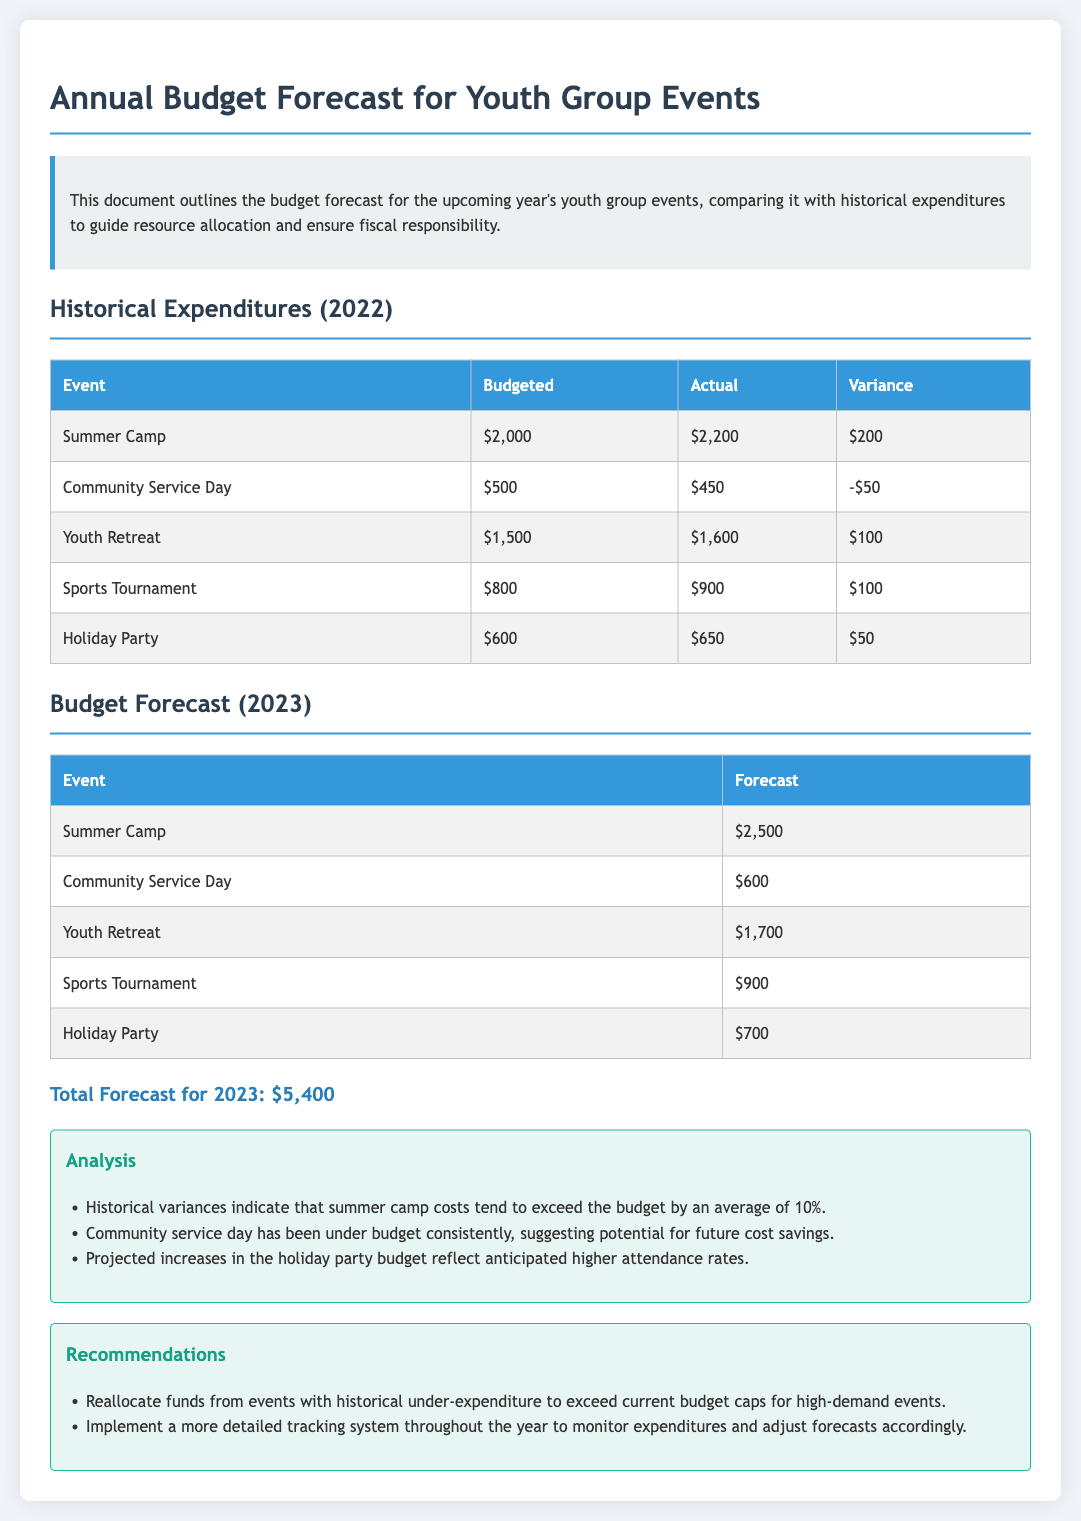What is the total budget for Summer Camp? The budget for Summer Camp in 2022 is listed as $2,000.
Answer: $2,000 What was the actual expenditure for Community Service Day in 2022? The actual expenditure for Community Service Day in 2022 was $450.
Answer: $450 What is the forecasted budget for the Youth Retreat in 2023? The forecasted budget for the Youth Retreat in 2023 is $1,700.
Answer: $1,700 How much did the Sports Tournament exceed its budget in 2022? The Sports Tournament exceeded its budget by $100 according to the variance table.
Answer: $100 What is the total forecast for 2023? The total forecast for 2023 is a summed amount of all forecasted events.
Answer: $5,400 Which event had the largest variance in 2022? The largest variance in 2022 was for the Summer Camp, with a variance of $200.
Answer: Summer Camp What does the analysis section indicate about the holiday party budget? The analysis indicates an anticipated increase in the holiday party budget due to higher expected attendance.
Answer: Higher attendance rates What recommendation is made regarding fund allocation? The recommendation is to reallocate funds from events that have had historical under-expenditure.
Answer: Reallocate funds How frequently do summer camp costs exceed the budget? The analysis mentions that summer camp costs tend to exceed the budget by an average of 10%.
Answer: Average of 10% 